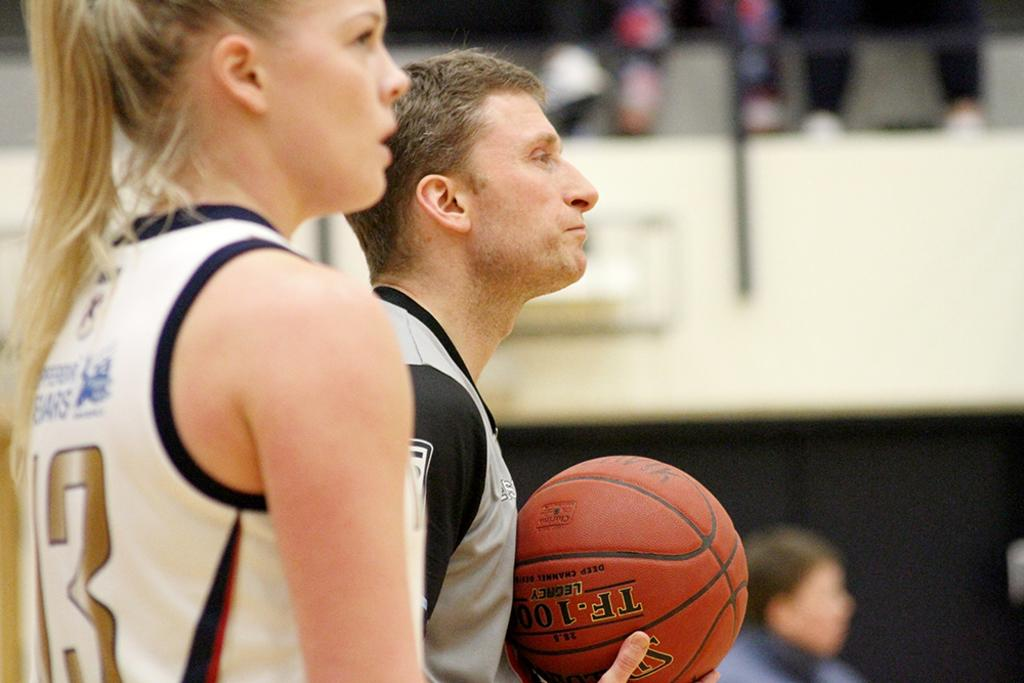<image>
Provide a brief description of the given image. Number 13 stands next to the referee who has the baskeball. 